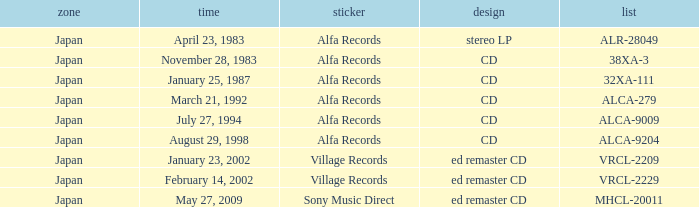Which date is in stereo lp format? April 23, 1983. 